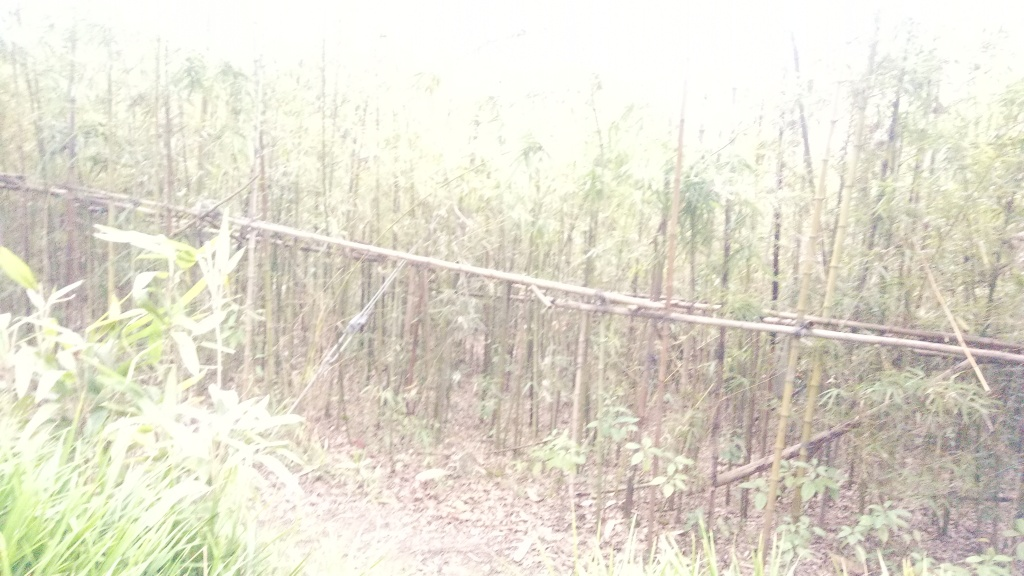Are there any quality issues with this image? Yes, there are quality issues with this image. It appears to be overexposed, which results in loss of detail and contrast. The lighting conditions seem to have affected the clarity of the image, making it difficult to discern finer details of the scene. Additionally, there seems to be blur which could originate from camera shake or movement, contributing to the overall poor quality of the photograph. 